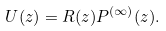Convert formula to latex. <formula><loc_0><loc_0><loc_500><loc_500>U ( z ) = R ( z ) P ^ { ( \infty ) } ( z ) .</formula> 